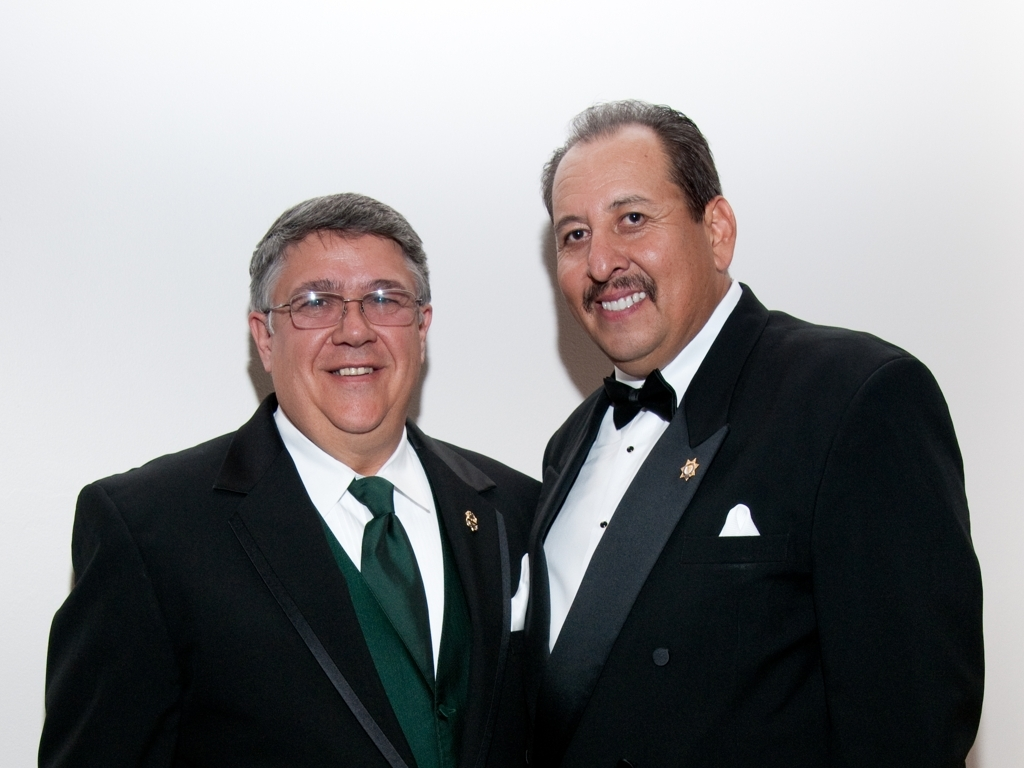How clear is the facial features in the image? The facial features in the image are very clear, showing two individuals sharply in focus. Each person's facial expressions, including smiles and eyes, are readily discernible, indicating a high-resolution photograph taken in good lighting conditions. 